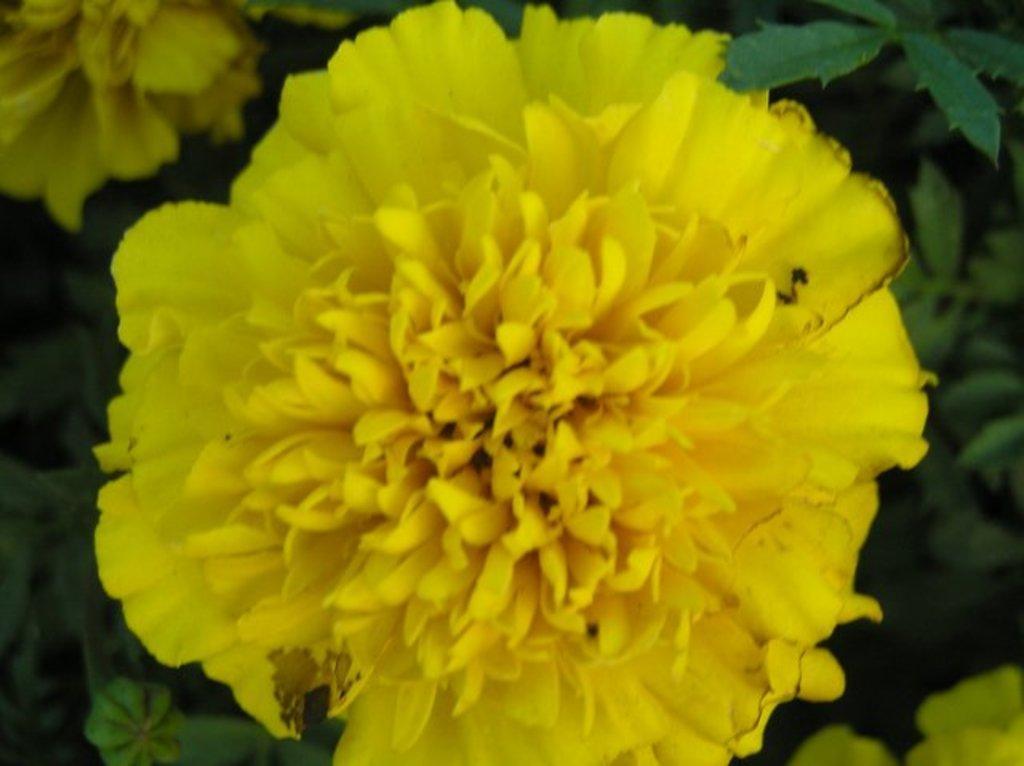Could you give a brief overview of what you see in this image? In this image we can see a flower of a plant. 